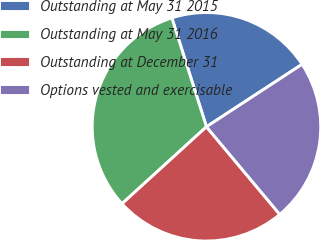Convert chart. <chart><loc_0><loc_0><loc_500><loc_500><pie_chart><fcel>Outstanding at May 31 2015<fcel>Outstanding at May 31 2016<fcel>Outstanding at December 31<fcel>Options vested and exercisable<nl><fcel>20.69%<fcel>31.86%<fcel>24.33%<fcel>23.12%<nl></chart> 